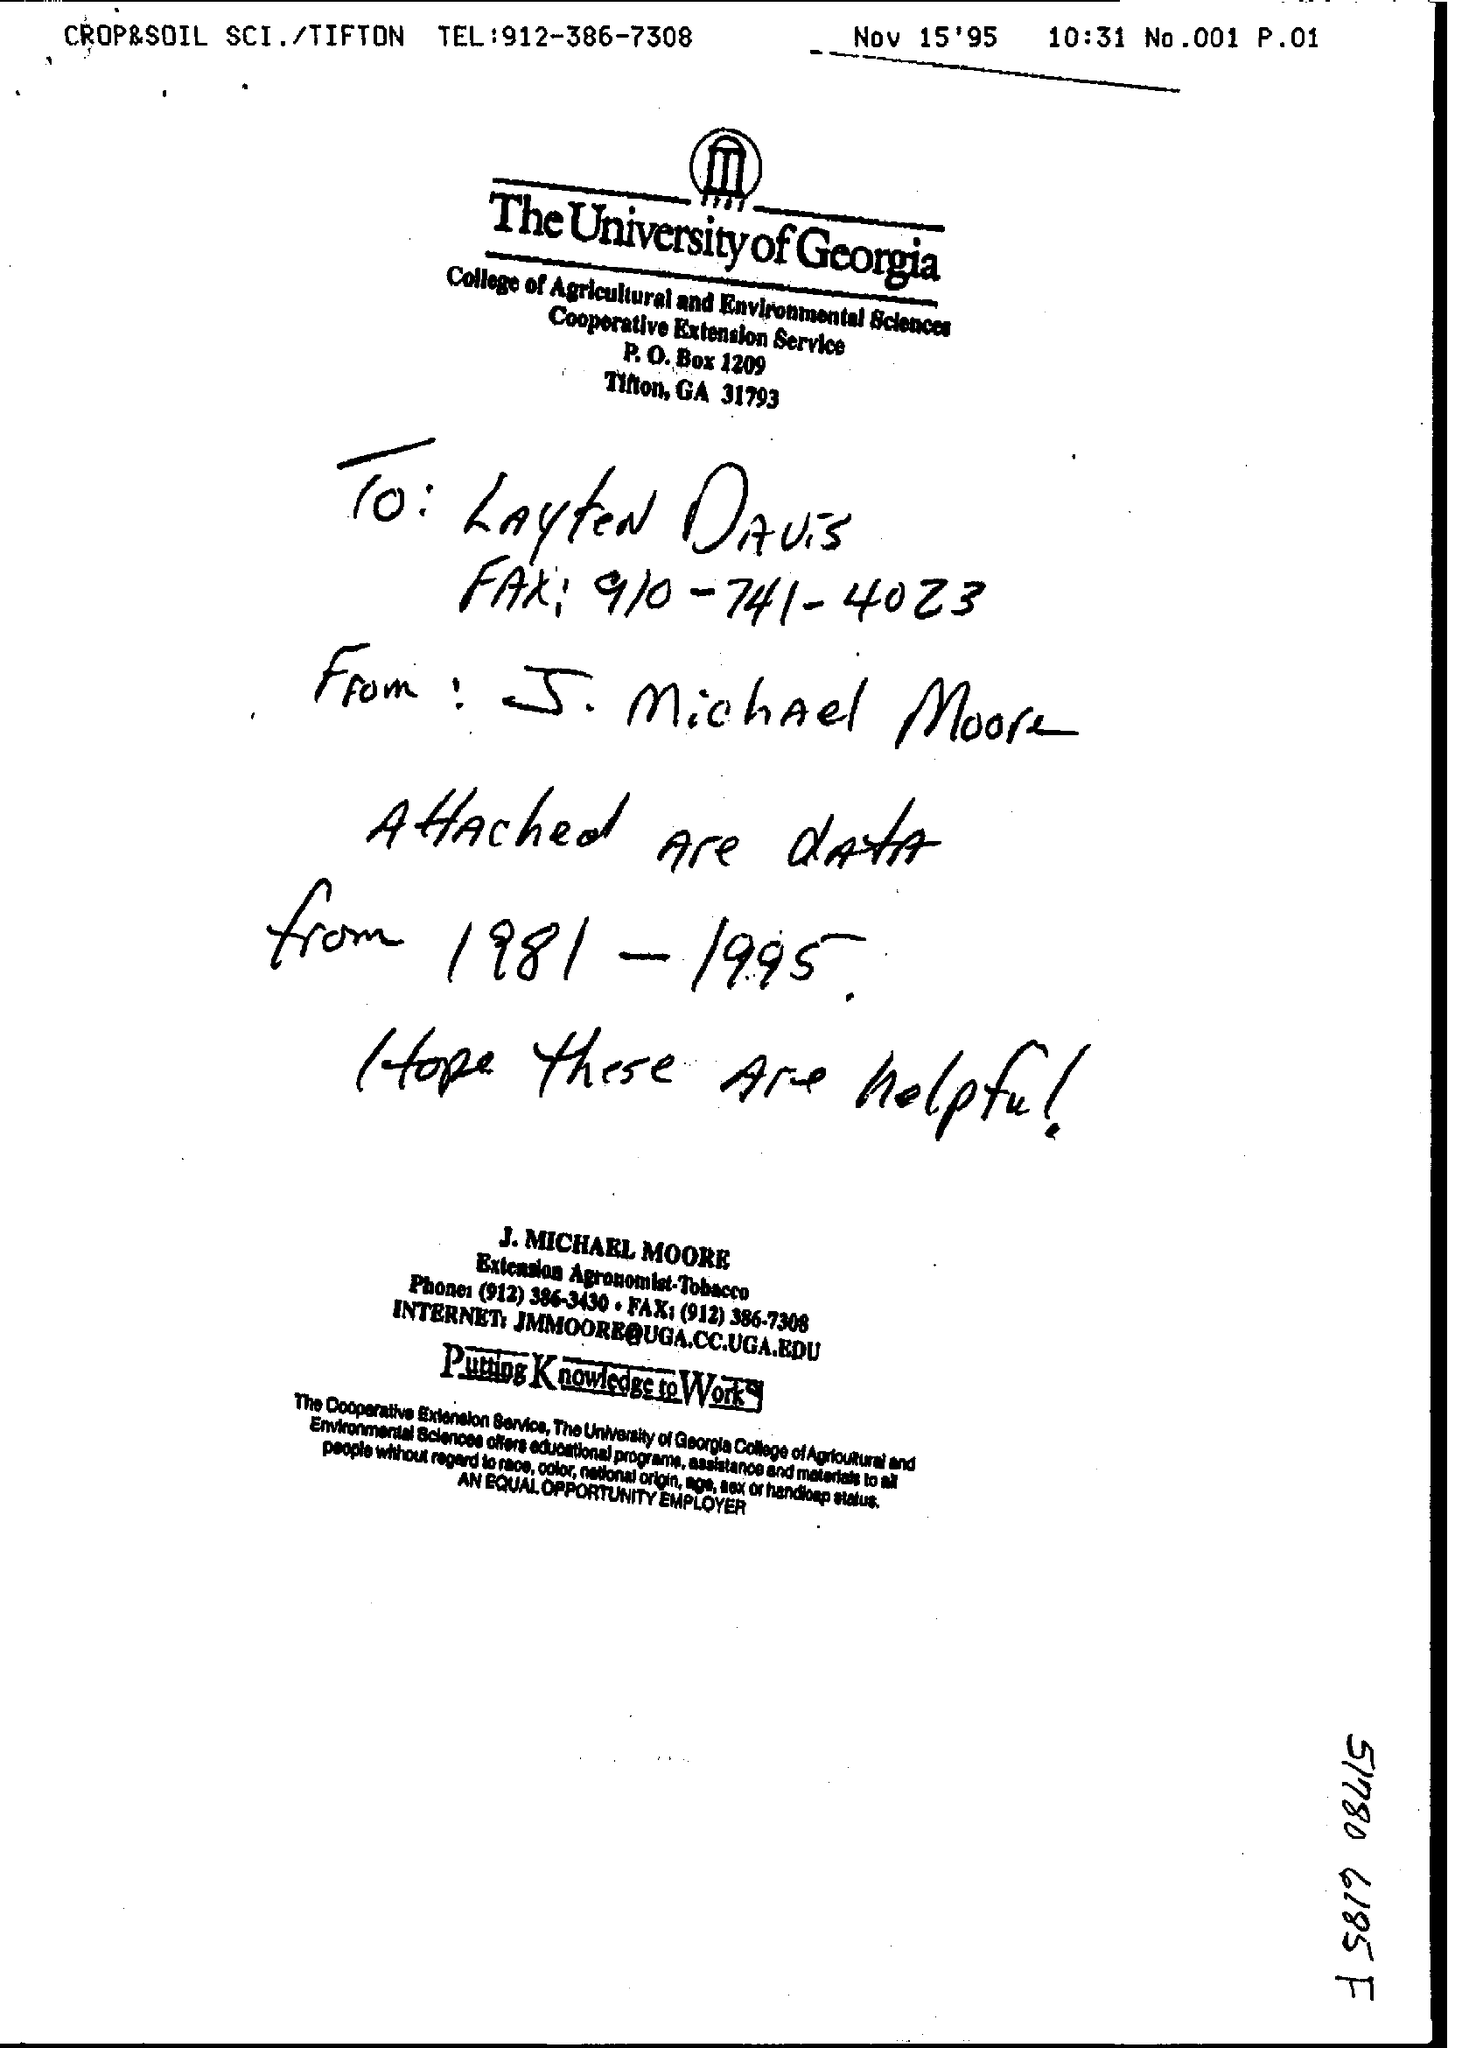Point out several critical features in this image. The phone number provided is (912) 386-3430. The note is addressed to a person named Layten Davis. 